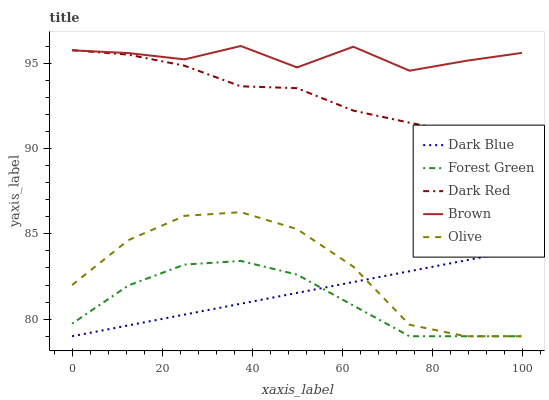Does Forest Green have the minimum area under the curve?
Answer yes or no. Yes. Does Brown have the maximum area under the curve?
Answer yes or no. Yes. Does Dark Blue have the minimum area under the curve?
Answer yes or no. No. Does Dark Blue have the maximum area under the curve?
Answer yes or no. No. Is Dark Blue the smoothest?
Answer yes or no. Yes. Is Brown the roughest?
Answer yes or no. Yes. Is Forest Green the smoothest?
Answer yes or no. No. Is Forest Green the roughest?
Answer yes or no. No. Does Olive have the lowest value?
Answer yes or no. Yes. Does Brown have the lowest value?
Answer yes or no. No. Does Brown have the highest value?
Answer yes or no. Yes. Does Dark Blue have the highest value?
Answer yes or no. No. Is Dark Blue less than Dark Red?
Answer yes or no. Yes. Is Brown greater than Dark Blue?
Answer yes or no. Yes. Does Forest Green intersect Dark Blue?
Answer yes or no. Yes. Is Forest Green less than Dark Blue?
Answer yes or no. No. Is Forest Green greater than Dark Blue?
Answer yes or no. No. Does Dark Blue intersect Dark Red?
Answer yes or no. No. 